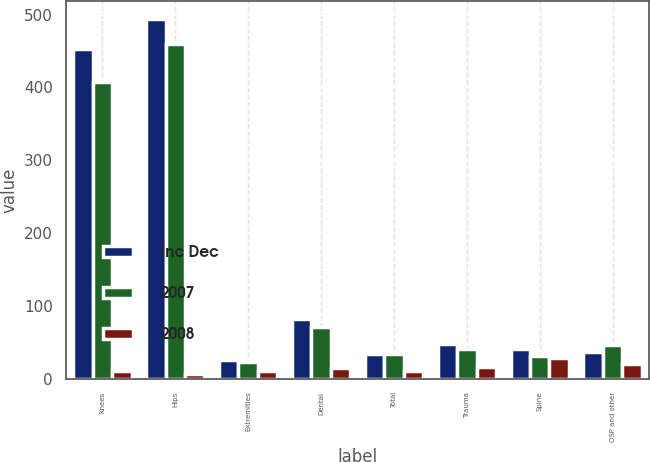Convert chart to OTSL. <chart><loc_0><loc_0><loc_500><loc_500><stacked_bar_chart><ecel><fcel>Knees<fcel>Hips<fcel>Extremities<fcel>Dental<fcel>Total<fcel>Trauma<fcel>Spine<fcel>OSP and other<nl><fcel>Inc Dec<fcel>452.6<fcel>493.9<fcel>25.8<fcel>82.2<fcel>34.15<fcel>47.4<fcel>40.1<fcel>37.1<nl><fcel>2007<fcel>407.8<fcel>459.9<fcel>23.2<fcel>71.3<fcel>34.15<fcel>41.1<fcel>31.2<fcel>46.5<nl><fcel>2008<fcel>11<fcel>7<fcel>11<fcel>15<fcel>10<fcel>16<fcel>29<fcel>20<nl></chart> 